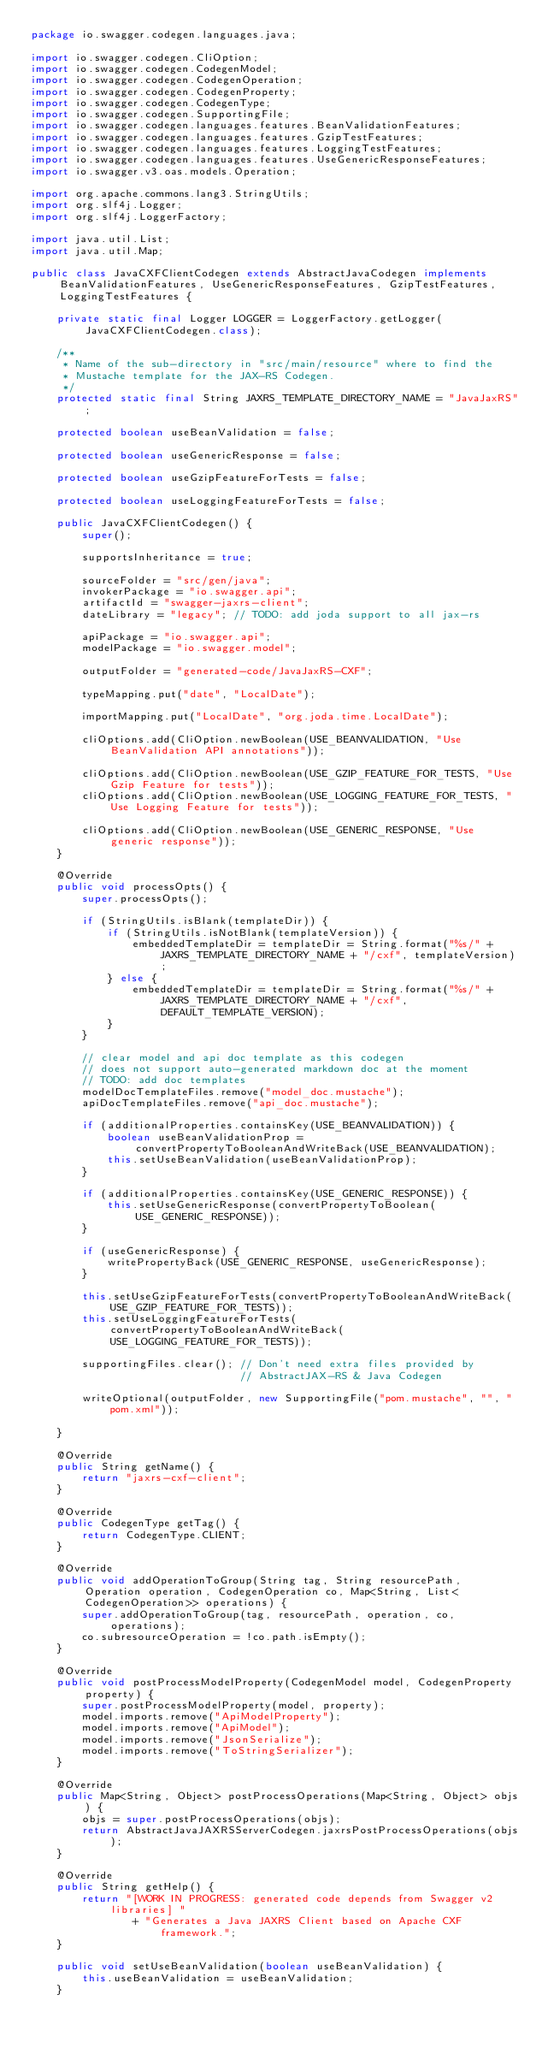Convert code to text. <code><loc_0><loc_0><loc_500><loc_500><_Java_>package io.swagger.codegen.languages.java;

import io.swagger.codegen.CliOption;
import io.swagger.codegen.CodegenModel;
import io.swagger.codegen.CodegenOperation;
import io.swagger.codegen.CodegenProperty;
import io.swagger.codegen.CodegenType;
import io.swagger.codegen.SupportingFile;
import io.swagger.codegen.languages.features.BeanValidationFeatures;
import io.swagger.codegen.languages.features.GzipTestFeatures;
import io.swagger.codegen.languages.features.LoggingTestFeatures;
import io.swagger.codegen.languages.features.UseGenericResponseFeatures;
import io.swagger.v3.oas.models.Operation;

import org.apache.commons.lang3.StringUtils;
import org.slf4j.Logger;
import org.slf4j.LoggerFactory;

import java.util.List;
import java.util.Map;

public class JavaCXFClientCodegen extends AbstractJavaCodegen implements BeanValidationFeatures, UseGenericResponseFeatures, GzipTestFeatures, LoggingTestFeatures {

    private static final Logger LOGGER = LoggerFactory.getLogger(JavaCXFClientCodegen.class);

    /**
     * Name of the sub-directory in "src/main/resource" where to find the
     * Mustache template for the JAX-RS Codegen.
     */
    protected static final String JAXRS_TEMPLATE_DIRECTORY_NAME = "JavaJaxRS";

    protected boolean useBeanValidation = false;

    protected boolean useGenericResponse = false;

    protected boolean useGzipFeatureForTests = false;

    protected boolean useLoggingFeatureForTests = false;

    public JavaCXFClientCodegen() {
        super();

        supportsInheritance = true;

        sourceFolder = "src/gen/java";
        invokerPackage = "io.swagger.api";
        artifactId = "swagger-jaxrs-client";
        dateLibrary = "legacy"; // TODO: add joda support to all jax-rs

        apiPackage = "io.swagger.api";
        modelPackage = "io.swagger.model";

        outputFolder = "generated-code/JavaJaxRS-CXF";

        typeMapping.put("date", "LocalDate");

        importMapping.put("LocalDate", "org.joda.time.LocalDate");

        cliOptions.add(CliOption.newBoolean(USE_BEANVALIDATION, "Use BeanValidation API annotations"));

        cliOptions.add(CliOption.newBoolean(USE_GZIP_FEATURE_FOR_TESTS, "Use Gzip Feature for tests"));
        cliOptions.add(CliOption.newBoolean(USE_LOGGING_FEATURE_FOR_TESTS, "Use Logging Feature for tests"));

        cliOptions.add(CliOption.newBoolean(USE_GENERIC_RESPONSE, "Use generic response"));
    }

    @Override
    public void processOpts() {
        super.processOpts();

        if (StringUtils.isBlank(templateDir)) {
            if (StringUtils.isNotBlank(templateVersion)) {
                embeddedTemplateDir = templateDir = String.format("%s/" + JAXRS_TEMPLATE_DIRECTORY_NAME + "/cxf", templateVersion);
            } else {
                embeddedTemplateDir = templateDir = String.format("%s/" + JAXRS_TEMPLATE_DIRECTORY_NAME + "/cxf", DEFAULT_TEMPLATE_VERSION);
            }
        }

        // clear model and api doc template as this codegen
        // does not support auto-generated markdown doc at the moment
        // TODO: add doc templates
        modelDocTemplateFiles.remove("model_doc.mustache");
        apiDocTemplateFiles.remove("api_doc.mustache");

        if (additionalProperties.containsKey(USE_BEANVALIDATION)) {
            boolean useBeanValidationProp = convertPropertyToBooleanAndWriteBack(USE_BEANVALIDATION);
            this.setUseBeanValidation(useBeanValidationProp);
        }

        if (additionalProperties.containsKey(USE_GENERIC_RESPONSE)) {
            this.setUseGenericResponse(convertPropertyToBoolean(USE_GENERIC_RESPONSE));
        }

        if (useGenericResponse) {
            writePropertyBack(USE_GENERIC_RESPONSE, useGenericResponse);
        }

        this.setUseGzipFeatureForTests(convertPropertyToBooleanAndWriteBack(USE_GZIP_FEATURE_FOR_TESTS));
        this.setUseLoggingFeatureForTests(convertPropertyToBooleanAndWriteBack(USE_LOGGING_FEATURE_FOR_TESTS));

        supportingFiles.clear(); // Don't need extra files provided by
                                 // AbstractJAX-RS & Java Codegen

        writeOptional(outputFolder, new SupportingFile("pom.mustache", "", "pom.xml"));

    }

    @Override
    public String getName() {
        return "jaxrs-cxf-client";
    }

    @Override
    public CodegenType getTag() {
        return CodegenType.CLIENT;
    }

    @Override
    public void addOperationToGroup(String tag, String resourcePath, Operation operation, CodegenOperation co, Map<String, List<CodegenOperation>> operations) {
        super.addOperationToGroup(tag, resourcePath, operation, co, operations);
        co.subresourceOperation = !co.path.isEmpty();
    }

    @Override
    public void postProcessModelProperty(CodegenModel model, CodegenProperty property) {
        super.postProcessModelProperty(model, property);
        model.imports.remove("ApiModelProperty");
        model.imports.remove("ApiModel");
        model.imports.remove("JsonSerialize");
        model.imports.remove("ToStringSerializer");
    }

    @Override
    public Map<String, Object> postProcessOperations(Map<String, Object> objs) {
        objs = super.postProcessOperations(objs);
        return AbstractJavaJAXRSServerCodegen.jaxrsPostProcessOperations(objs);
    }

    @Override
    public String getHelp() {
        return "[WORK IN PROGRESS: generated code depends from Swagger v2 libraries] "
                + "Generates a Java JAXRS Client based on Apache CXF framework.";
    }

    public void setUseBeanValidation(boolean useBeanValidation) {
        this.useBeanValidation = useBeanValidation;
    }
</code> 